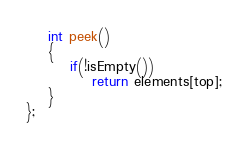Convert code to text. <code><loc_0><loc_0><loc_500><loc_500><_C++_>
	int peek()
	{
		if(!isEmpty())
			return elements[top];
	}
};

</code> 